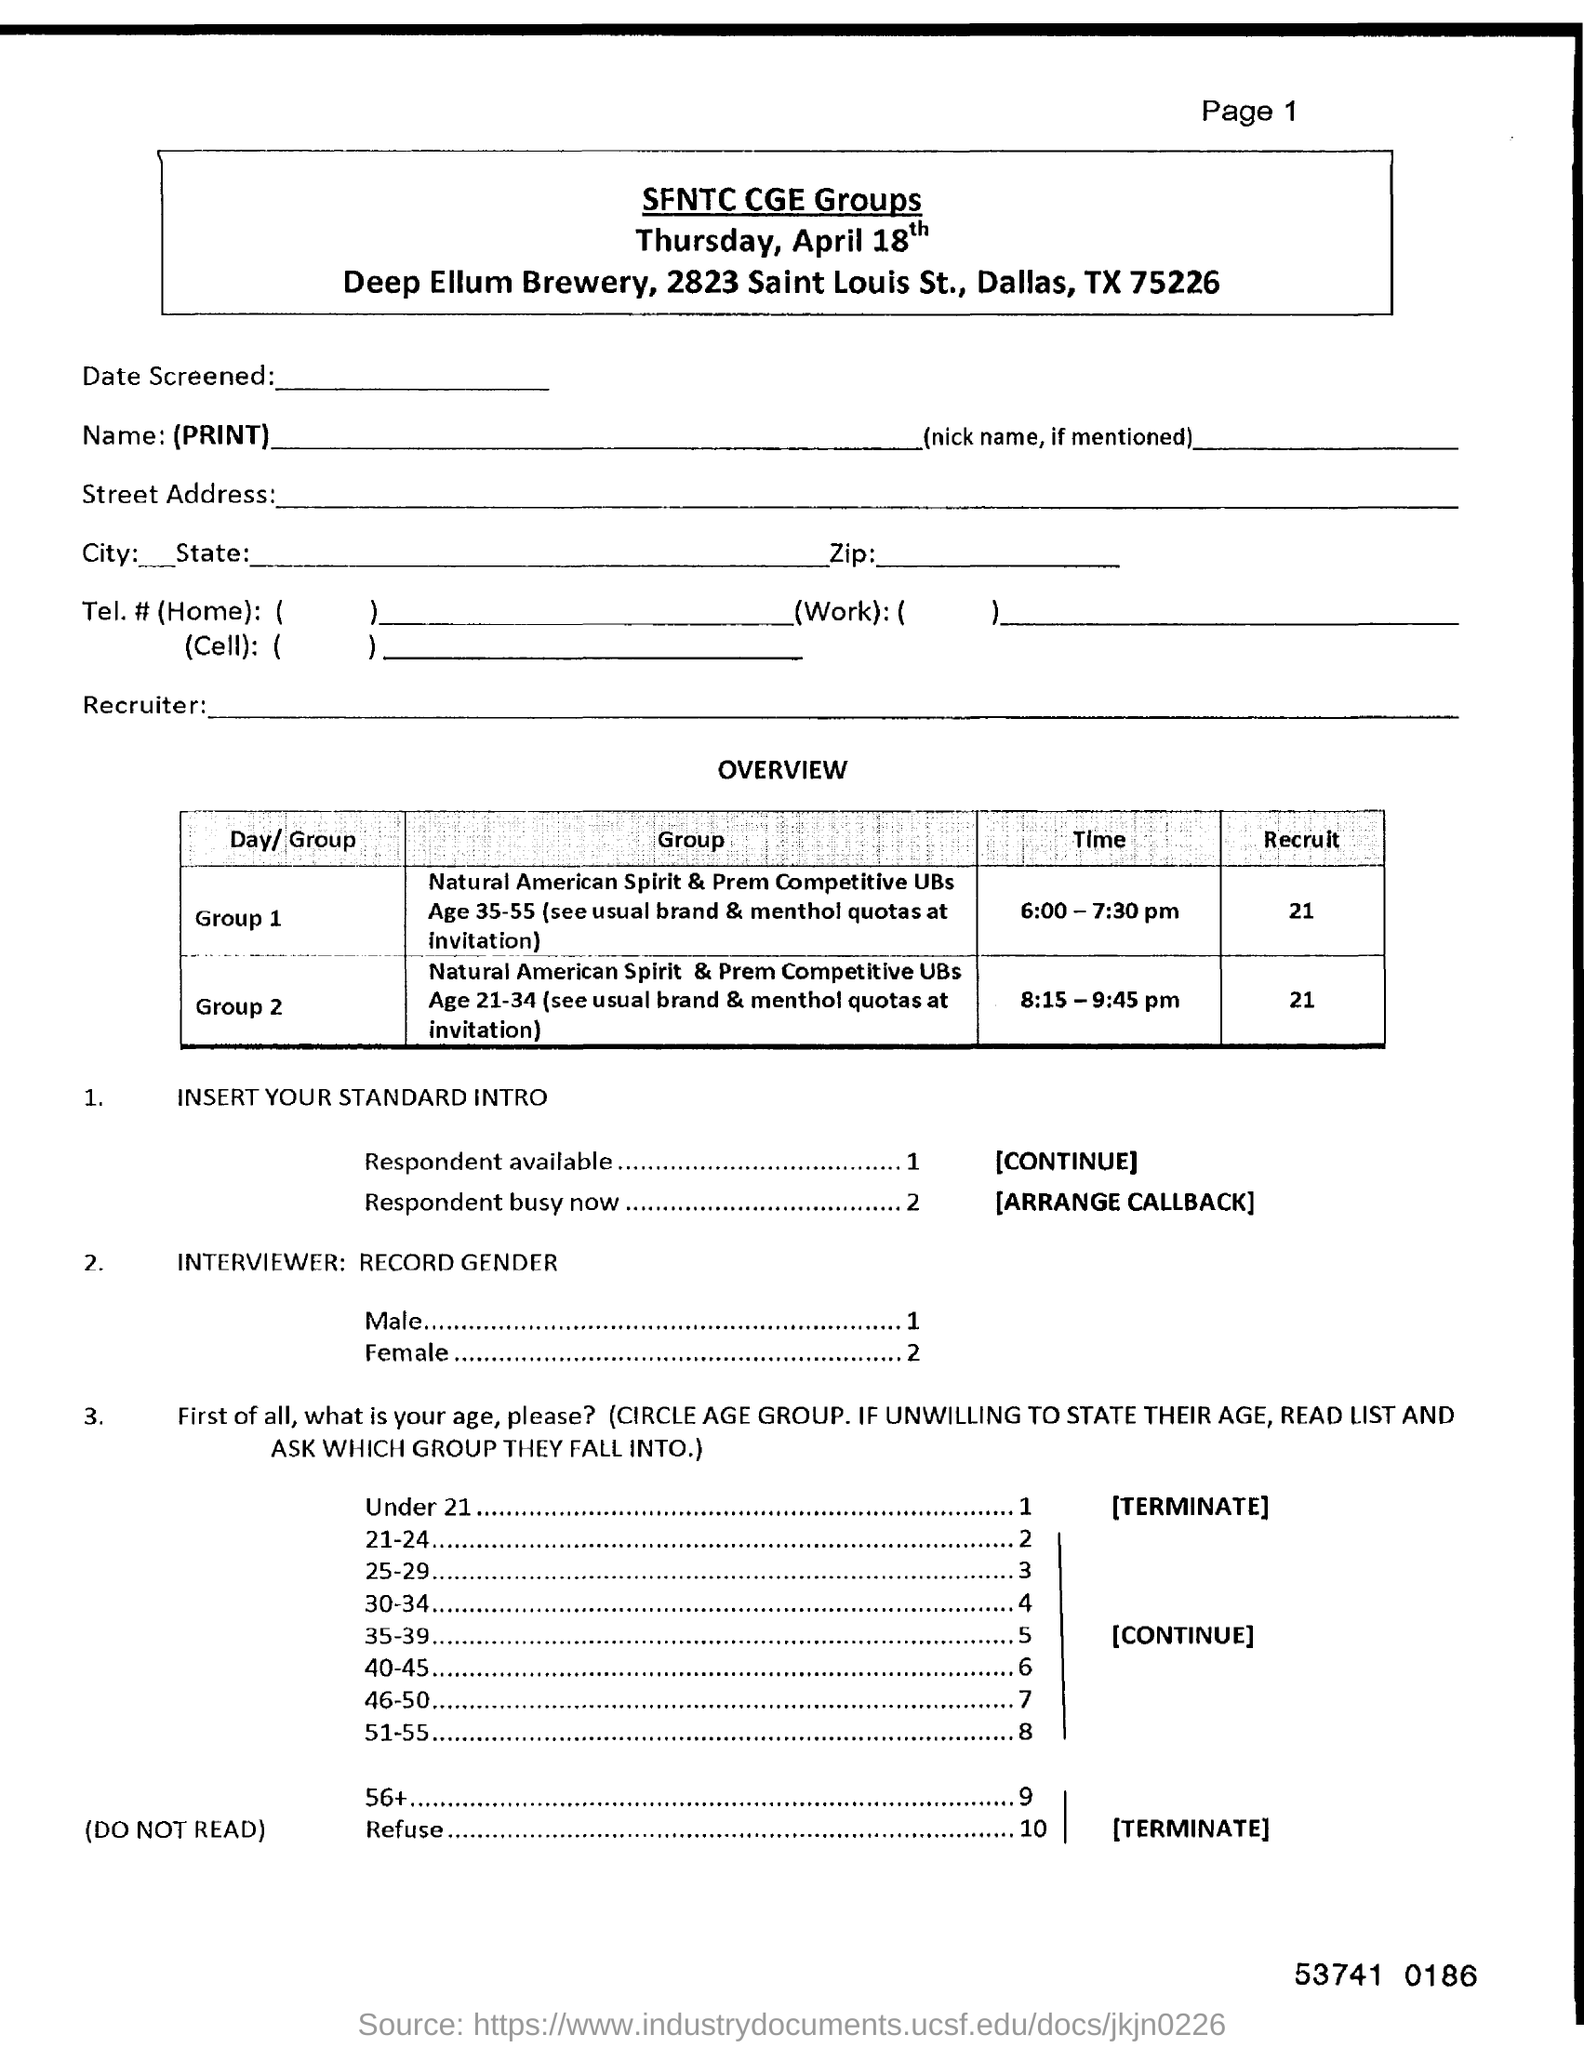Indicate a few pertinent items in this graphic. There are 21 recruits in Group 1. The zip code mentioned is 75226. The number written at the bottom of the page is 53,741, followed by a series of digits and a space, and then the digit 0 and then the letter 'e,' followed by another space, and finally the digits 186. The page number on this document is 1. 